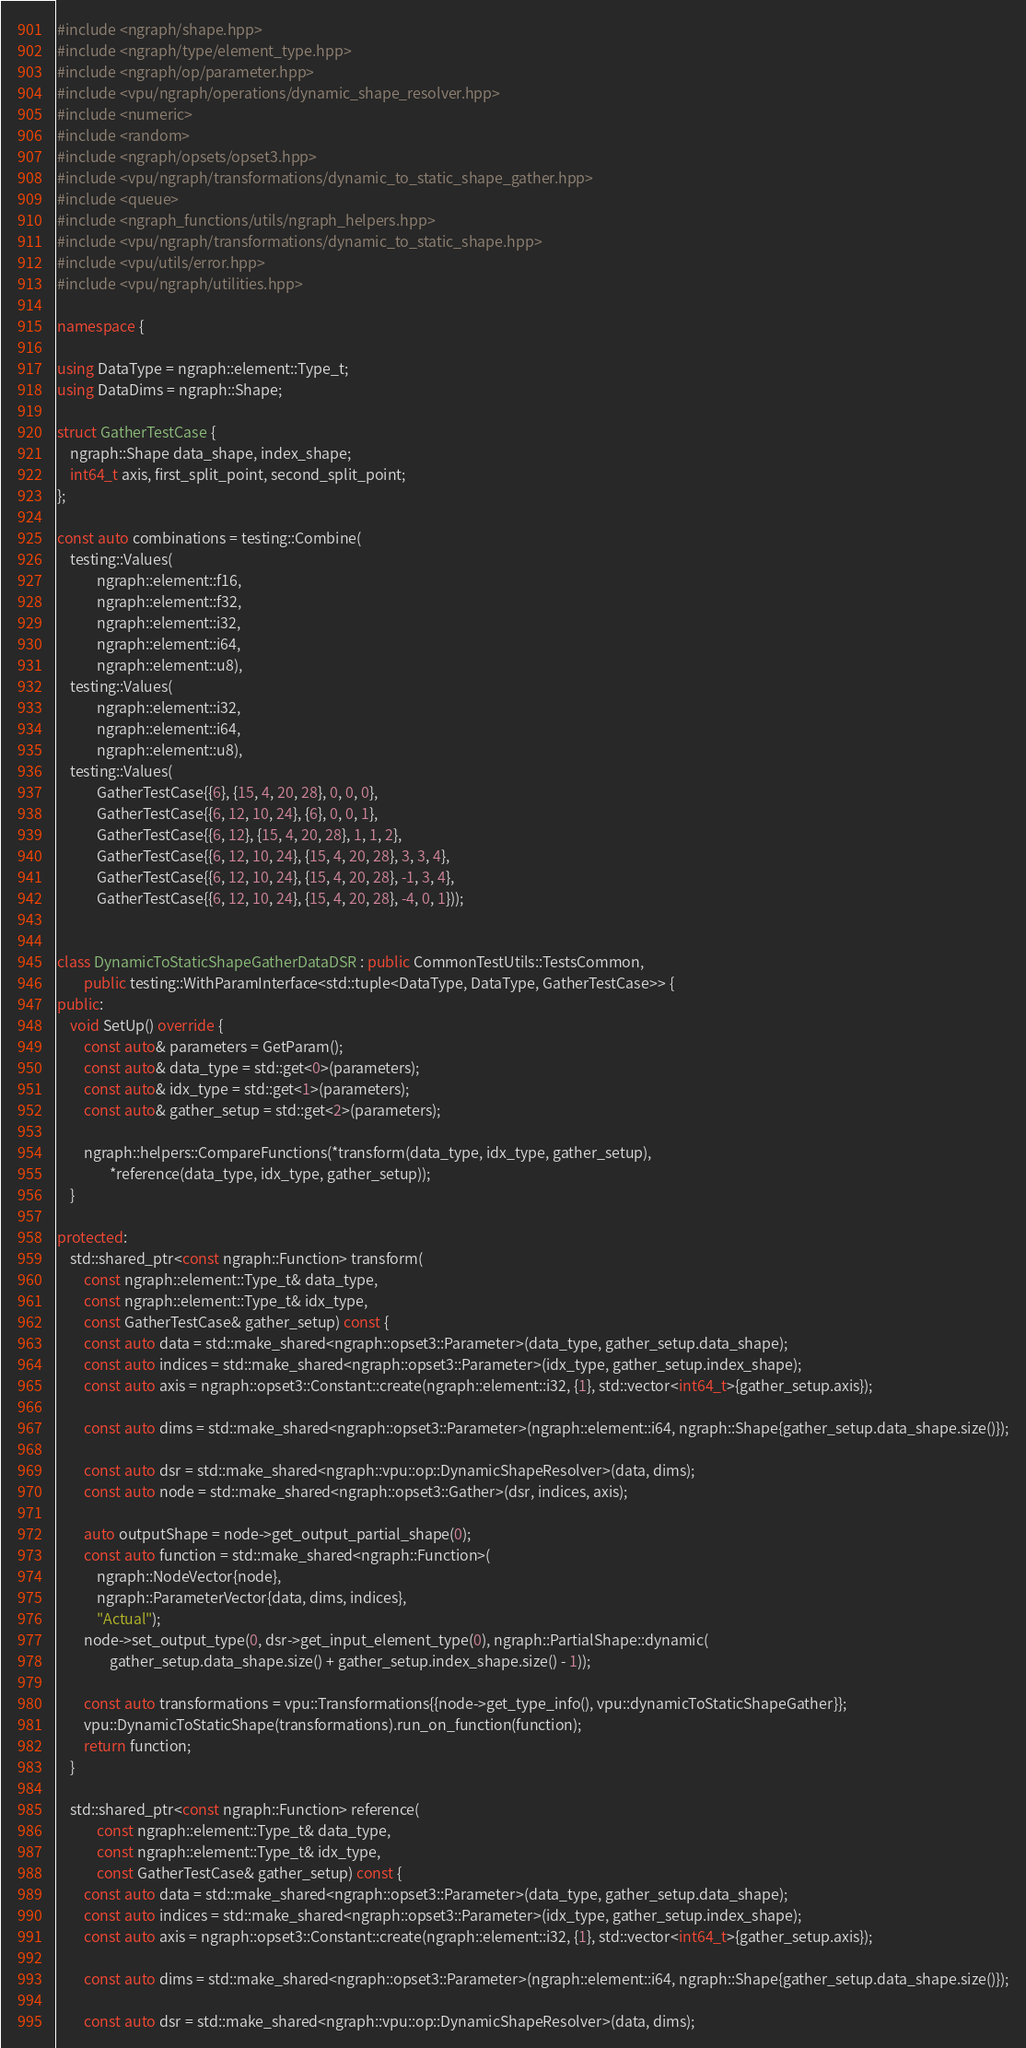<code> <loc_0><loc_0><loc_500><loc_500><_C++_>#include <ngraph/shape.hpp>
#include <ngraph/type/element_type.hpp>
#include <ngraph/op/parameter.hpp>
#include <vpu/ngraph/operations/dynamic_shape_resolver.hpp>
#include <numeric>
#include <random>
#include <ngraph/opsets/opset3.hpp>
#include <vpu/ngraph/transformations/dynamic_to_static_shape_gather.hpp>
#include <queue>
#include <ngraph_functions/utils/ngraph_helpers.hpp>
#include <vpu/ngraph/transformations/dynamic_to_static_shape.hpp>
#include <vpu/utils/error.hpp>
#include <vpu/ngraph/utilities.hpp>

namespace {

using DataType = ngraph::element::Type_t;
using DataDims = ngraph::Shape;

struct GatherTestCase {
    ngraph::Shape data_shape, index_shape;
    int64_t axis, first_split_point, second_split_point;
};

const auto combinations = testing::Combine(
    testing::Values(
            ngraph::element::f16,
            ngraph::element::f32,
            ngraph::element::i32,
            ngraph::element::i64,
            ngraph::element::u8),
    testing::Values(
            ngraph::element::i32,
            ngraph::element::i64,
            ngraph::element::u8),
    testing::Values(
            GatherTestCase{{6}, {15, 4, 20, 28}, 0, 0, 0},
            GatherTestCase{{6, 12, 10, 24}, {6}, 0, 0, 1},
            GatherTestCase{{6, 12}, {15, 4, 20, 28}, 1, 1, 2},
            GatherTestCase{{6, 12, 10, 24}, {15, 4, 20, 28}, 3, 3, 4},
            GatherTestCase{{6, 12, 10, 24}, {15, 4, 20, 28}, -1, 3, 4},
            GatherTestCase{{6, 12, 10, 24}, {15, 4, 20, 28}, -4, 0, 1}));


class DynamicToStaticShapeGatherDataDSR : public CommonTestUtils::TestsCommon,
        public testing::WithParamInterface<std::tuple<DataType, DataType, GatherTestCase>> {
public:
    void SetUp() override {
        const auto& parameters = GetParam();
        const auto& data_type = std::get<0>(parameters);
        const auto& idx_type = std::get<1>(parameters);
        const auto& gather_setup = std::get<2>(parameters);

        ngraph::helpers::CompareFunctions(*transform(data_type, idx_type, gather_setup),
                *reference(data_type, idx_type, gather_setup));
    }

protected:
    std::shared_ptr<const ngraph::Function> transform(
        const ngraph::element::Type_t& data_type,
        const ngraph::element::Type_t& idx_type,
        const GatherTestCase& gather_setup) const {
        const auto data = std::make_shared<ngraph::opset3::Parameter>(data_type, gather_setup.data_shape);
        const auto indices = std::make_shared<ngraph::opset3::Parameter>(idx_type, gather_setup.index_shape);
        const auto axis = ngraph::opset3::Constant::create(ngraph::element::i32, {1}, std::vector<int64_t>{gather_setup.axis});

        const auto dims = std::make_shared<ngraph::opset3::Parameter>(ngraph::element::i64, ngraph::Shape{gather_setup.data_shape.size()});

        const auto dsr = std::make_shared<ngraph::vpu::op::DynamicShapeResolver>(data, dims);
        const auto node = std::make_shared<ngraph::opset3::Gather>(dsr, indices, axis);

        auto outputShape = node->get_output_partial_shape(0);
        const auto function = std::make_shared<ngraph::Function>(
            ngraph::NodeVector{node},
            ngraph::ParameterVector{data, dims, indices},
            "Actual");
        node->set_output_type(0, dsr->get_input_element_type(0), ngraph::PartialShape::dynamic(
                gather_setup.data_shape.size() + gather_setup.index_shape.size() - 1));

        const auto transformations = vpu::Transformations{{node->get_type_info(), vpu::dynamicToStaticShapeGather}};
        vpu::DynamicToStaticShape(transformations).run_on_function(function);
        return function;
    }

    std::shared_ptr<const ngraph::Function> reference(
            const ngraph::element::Type_t& data_type,
            const ngraph::element::Type_t& idx_type,
            const GatherTestCase& gather_setup) const {
        const auto data = std::make_shared<ngraph::opset3::Parameter>(data_type, gather_setup.data_shape);
        const auto indices = std::make_shared<ngraph::opset3::Parameter>(idx_type, gather_setup.index_shape);
        const auto axis = ngraph::opset3::Constant::create(ngraph::element::i32, {1}, std::vector<int64_t>{gather_setup.axis});

        const auto dims = std::make_shared<ngraph::opset3::Parameter>(ngraph::element::i64, ngraph::Shape{gather_setup.data_shape.size()});

        const auto dsr = std::make_shared<ngraph::vpu::op::DynamicShapeResolver>(data, dims);</code> 